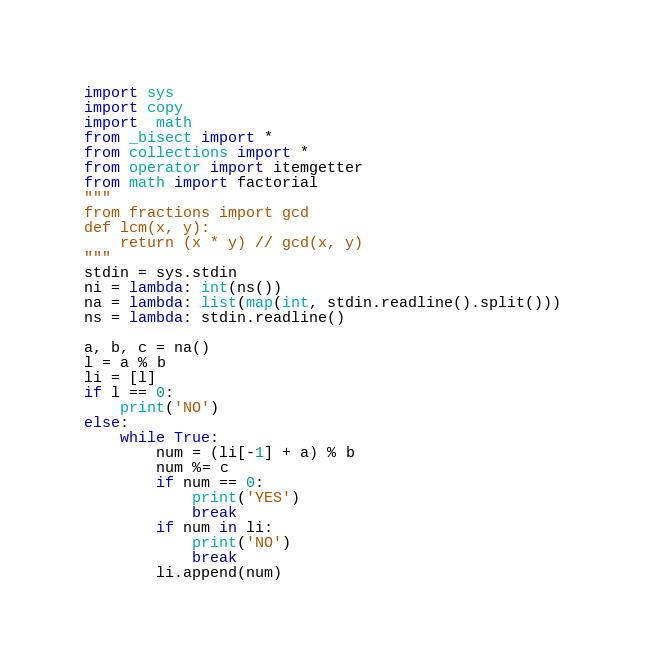<code> <loc_0><loc_0><loc_500><loc_500><_Python_>import sys
import copy
import  math
from _bisect import *
from collections import *
from operator import itemgetter
from math import factorial
"""
from fractions import gcd
def lcm(x, y):
    return (x * y) // gcd(x, y)
"""
stdin = sys.stdin
ni = lambda: int(ns())
na = lambda: list(map(int, stdin.readline().split()))
ns = lambda: stdin.readline()

a, b, c = na()
l = a % b
li = [l]
if l == 0:
    print('NO')
else:
    while True:
        num = (li[-1] + a) % b
        num %= c
        if num == 0:
            print('YES')
            break
        if num in li:
            print('NO')
            break
        li.append(num)

</code> 